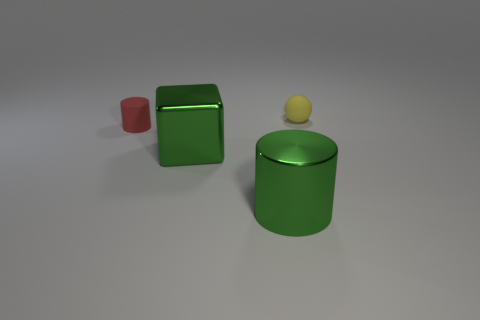How many other objects are the same material as the red object?
Make the answer very short. 1. What is the material of the cylinder that is the same size as the matte sphere?
Your response must be concise. Rubber. Is the number of tiny objects to the right of the big green metallic cylinder greater than the number of metallic things that are behind the small yellow sphere?
Provide a succinct answer. Yes. Are there any big green metallic things that have the same shape as the red object?
Make the answer very short. Yes. There is another thing that is the same size as the red object; what is its shape?
Your answer should be compact. Sphere. There is a tiny matte thing that is on the right side of the large green cube; what shape is it?
Provide a short and direct response. Sphere. Are there fewer small yellow matte objects to the left of the ball than large green shiny objects to the left of the large cylinder?
Keep it short and to the point. Yes. Is the size of the yellow rubber object the same as the green thing in front of the green metal block?
Give a very brief answer. No. How many spheres have the same size as the red rubber cylinder?
Make the answer very short. 1. There is a tiny cylinder that is made of the same material as the yellow sphere; what color is it?
Your answer should be compact. Red. 